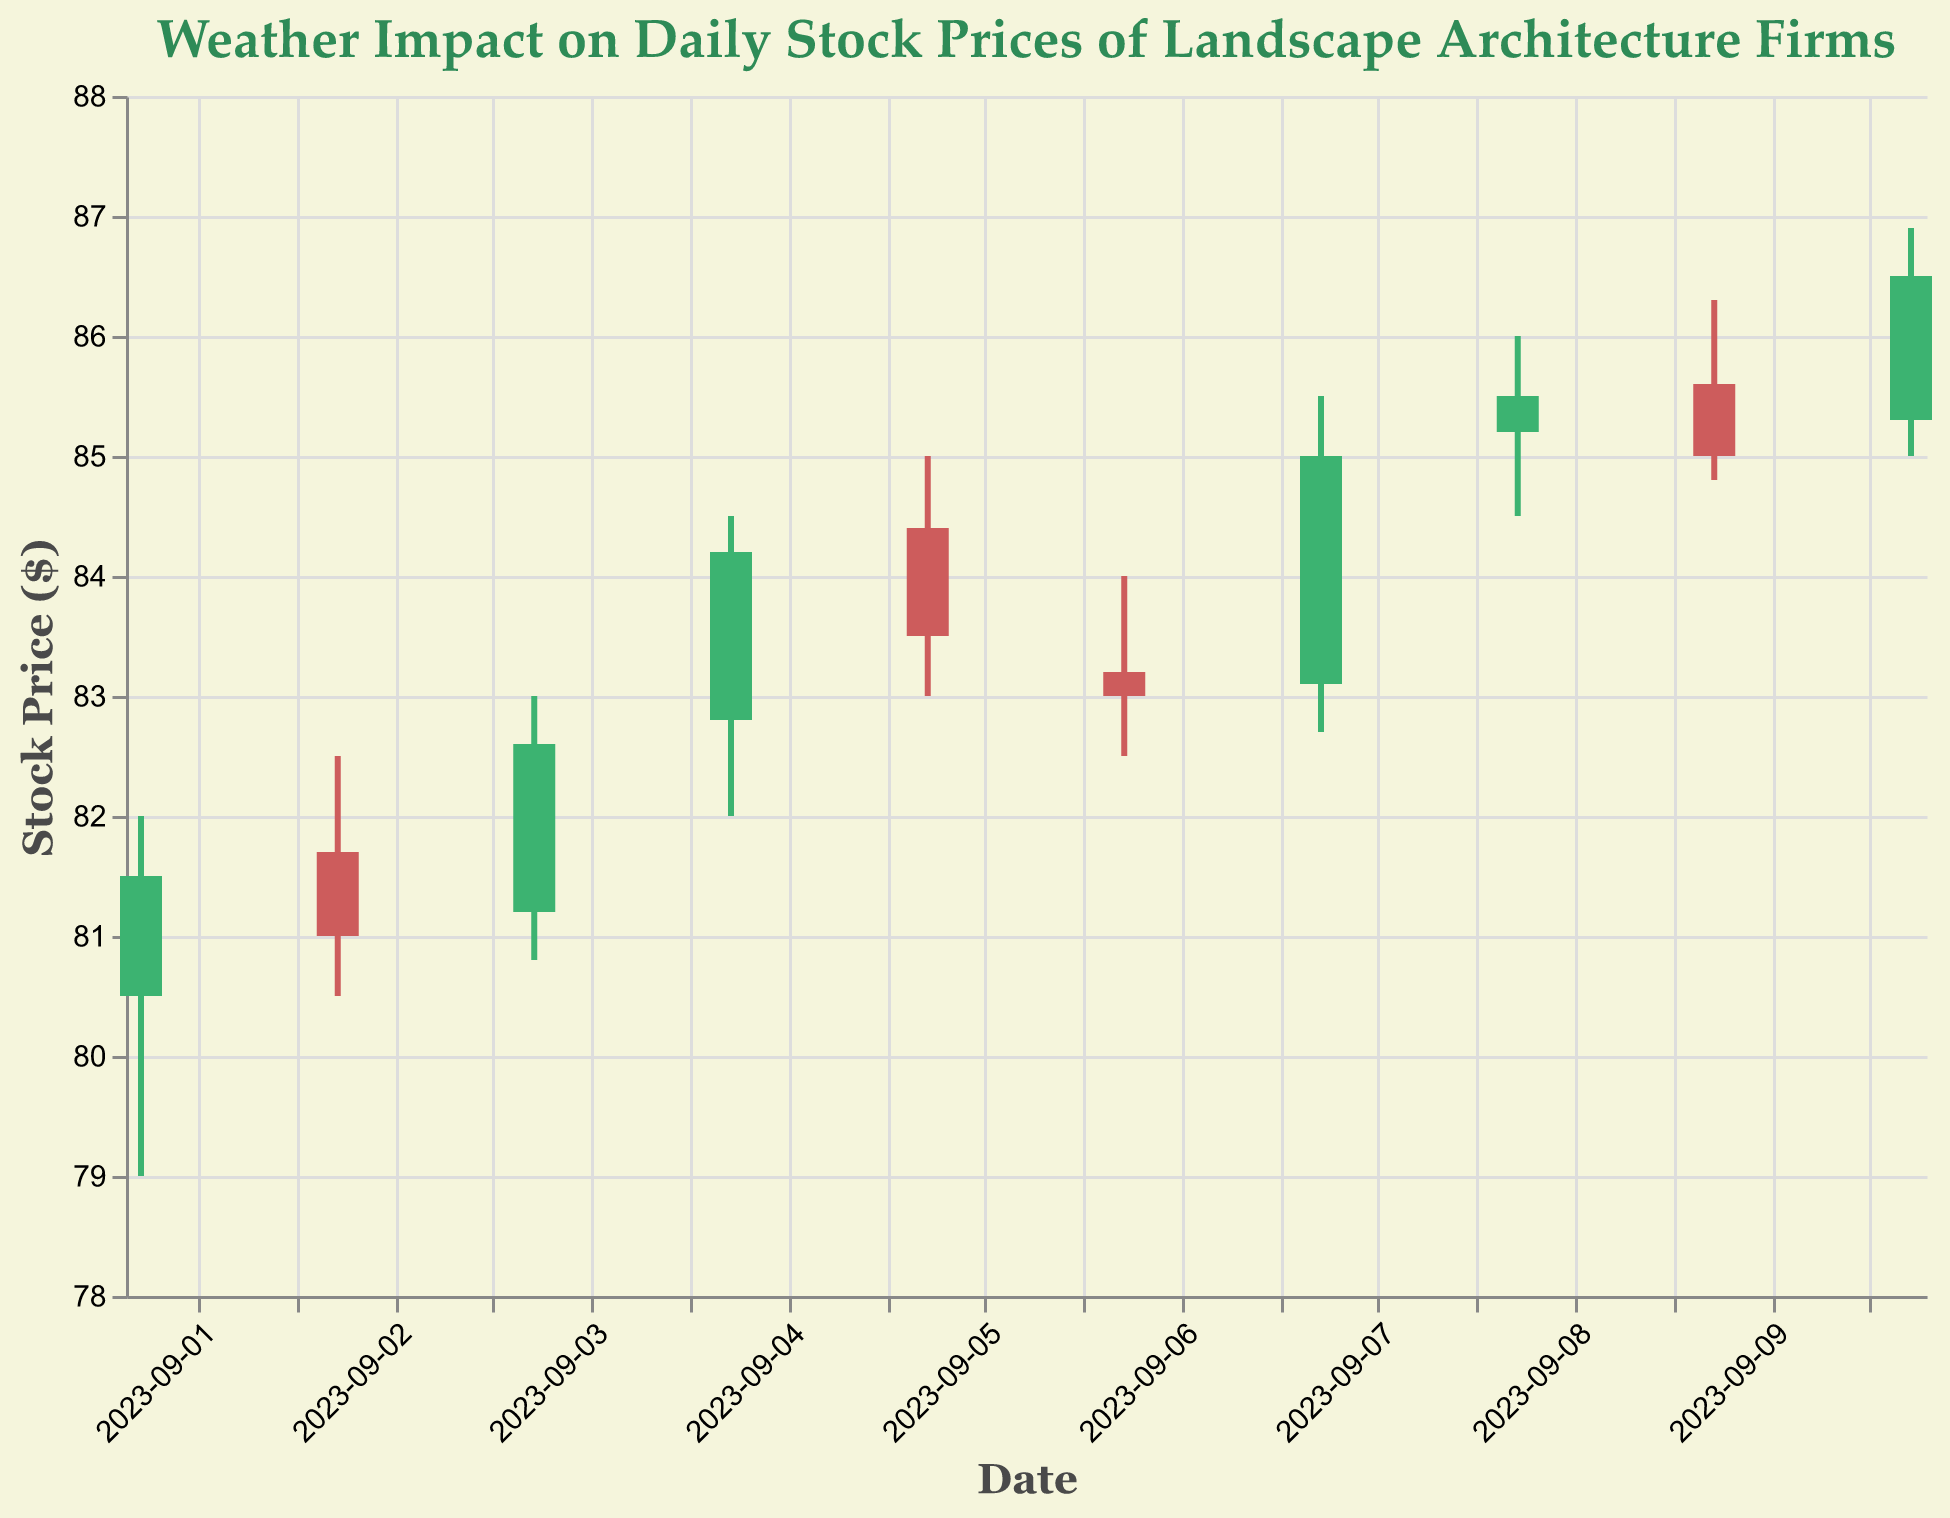What's the title of the figure? The title is located at the top of the figure and usually describes the content or purpose of the visualization. Here, it reads "Weather Impact on Daily Stock Prices of Landscape Architecture Firms".
Answer: Weather Impact on Daily Stock Prices of Landscape Architecture Firms On which date did the stock reach its highest price? To find the date with the highest price, examine the 'High' values in the candlestick plot. The highest price is 86.90 on September 10th, 2023.
Answer: 2023-09-10 How many days in the plot experienced sunny weather? The plot lists the weather for each date; count the occurrences of "Sunny" in the dataset. There are 6 days with sunny weather.
Answer: 6 What was the stock's closing price on the first day? Look at the candlestick representing September 1, 2023, and identify the closing price, which is marked by the end of the candle that points to the right. The closing price is 81.50.
Answer: 81.50 Compare the stock's opening price on September 1st and September 5th. Which was higher? Identify the candlestick for September 1st and September 5th and compare the opening prices. September 1st opened at 80.50, while September 5th opened at 84.40. Therefore, September 5th had a higher opening price.
Answer: September 5th What was the price difference between the highest and lowest stock price on September 8, 2023? Locate the candlestick for September 8, 2023, and find the 'High' and 'Low' prices. Subtract the lowest price from the highest price: 86.00 - 84.50 = 1.50.
Answer: 1.50 Was there any day where the stock closed lower than it opened and also had cloudy weather? Find the days with cloudy weather and check if the closing price is less than the opening price. September 2, 2023, and September 6, 2023, meet the criteria as both have cloudy weather and closing prices lower than their opening prices.
Answer: Yes Calculate the average closing price on sunny days. Extract the closing prices for sunny days and compute the average: (81.50 + 82.60 + 84.20 + 85.00 + 85.50 + 86.50) / 6 = 84.22.
Answer: 84.22 Which day had the lowest trading volume and what was it? Look at the 'Volume' data points and identify the lowest value. September 2, 2023, had the lowest trading volume with 130000.
Answer: September 2, 130000 Did the stock price ever drop below 80 on any day? Check the 'Low' price across all candlestick plots to see if any price fell below 80. The lowest value is 79.00 on September 1, 2023.
Answer: Yes 